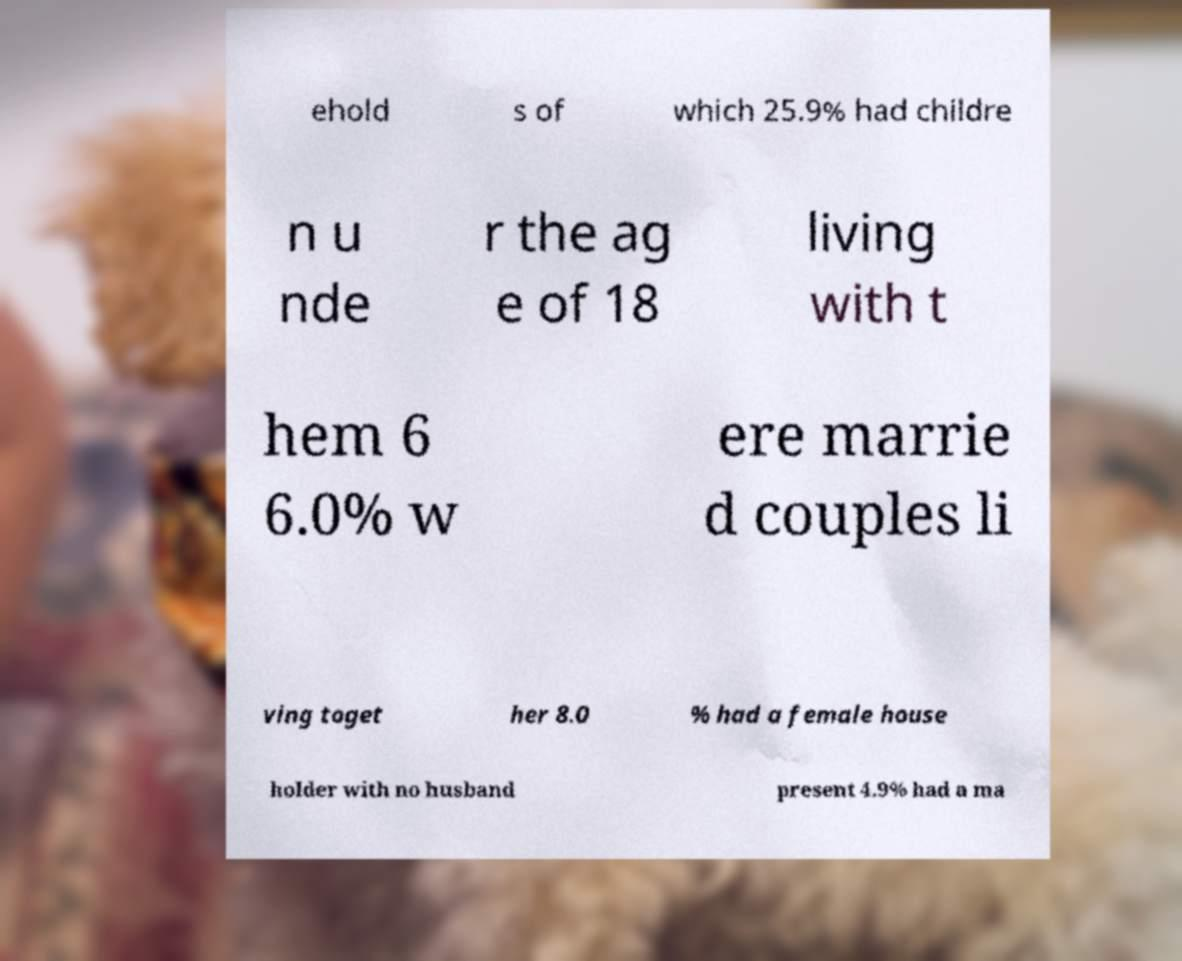There's text embedded in this image that I need extracted. Can you transcribe it verbatim? ehold s of which 25.9% had childre n u nde r the ag e of 18 living with t hem 6 6.0% w ere marrie d couples li ving toget her 8.0 % had a female house holder with no husband present 4.9% had a ma 